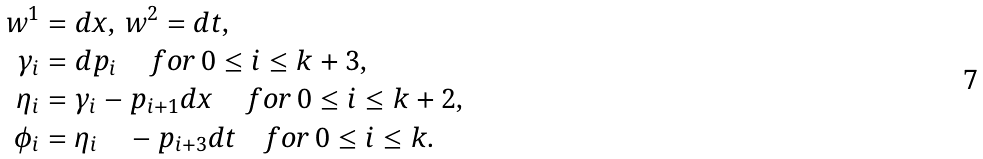<formula> <loc_0><loc_0><loc_500><loc_500>w ^ { 1 } & = d x , \, w ^ { 2 } = d t , \\ \gamma _ { i } & = d p _ { i } \, \quad f o r \, 0 \leq i \leq k + 3 , \\ \eta _ { i } & = \gamma _ { i } - p _ { i + 1 } d x \quad \, f o r \, 0 \leq i \leq k + 2 , \\ \phi _ { i } & = \eta _ { i } \quad - p _ { i + 3 } d t \quad f o r \, 0 \leq i \leq k .</formula> 